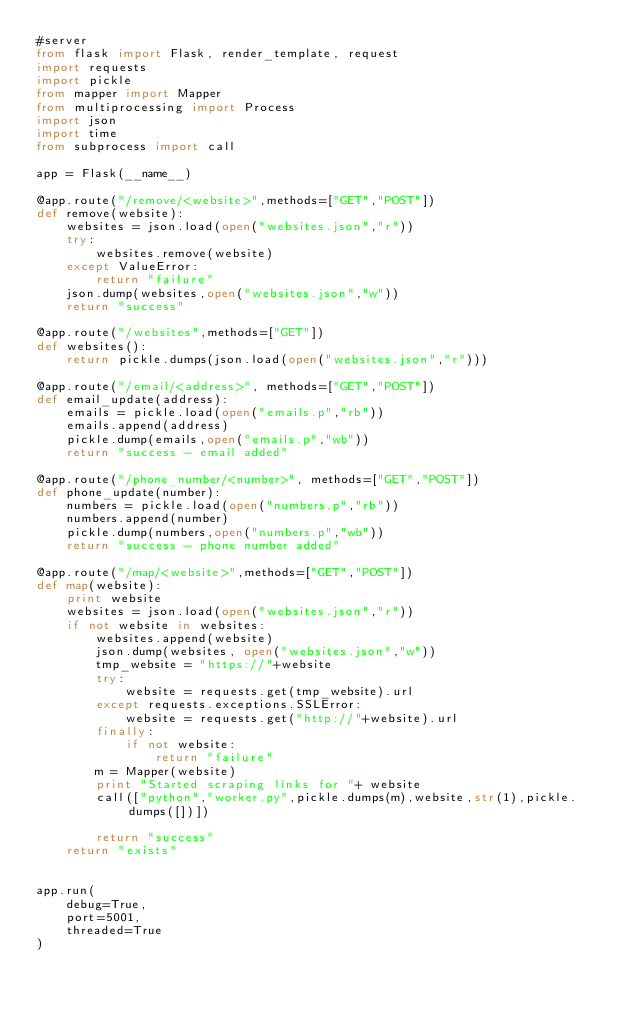Convert code to text. <code><loc_0><loc_0><loc_500><loc_500><_Python_>#server
from flask import Flask, render_template, request
import requests
import pickle
from mapper import Mapper
from multiprocessing import Process
import json
import time
from subprocess import call

app = Flask(__name__)

@app.route("/remove/<website>",methods=["GET","POST"])
def remove(website):
    websites = json.load(open("websites.json","r"))
    try:
        websites.remove(website)
    except ValueError:
        return "failure"
    json.dump(websites,open("websites.json","w"))
    return "success"

@app.route("/websites",methods=["GET"])
def websites():
    return pickle.dumps(json.load(open("websites.json","r")))

@app.route("/email/<address>", methods=["GET","POST"])
def email_update(address):
    emails = pickle.load(open("emails.p","rb"))
    emails.append(address)
    pickle.dump(emails,open("emails.p","wb"))
    return "success - email added"

@app.route("/phone_number/<number>", methods=["GET","POST"])
def phone_update(number):
    numbers = pickle.load(open("numbers.p","rb"))
    numbers.append(number)
    pickle.dump(numbers,open("numbers.p","wb"))
    return "success - phone number added"

@app.route("/map/<website>",methods=["GET","POST"])
def map(website):
    print website
    websites = json.load(open("websites.json","r"))
    if not website in websites:
        websites.append(website)
        json.dump(websites, open("websites.json","w"))
        tmp_website = "https://"+website
        try:
            website = requests.get(tmp_website).url
        except requests.exceptions.SSLError:
            website = requests.get("http://"+website).url
        finally:
            if not website:
                return "failure"
        m = Mapper(website)
        print "Started scraping links for "+ website
        call(["python","worker.py",pickle.dumps(m),website,str(1),pickle.dumps([])])
        
        return "success"
    return "exists"


app.run(
    debug=True,
    port=5001,
    threaded=True
)
</code> 